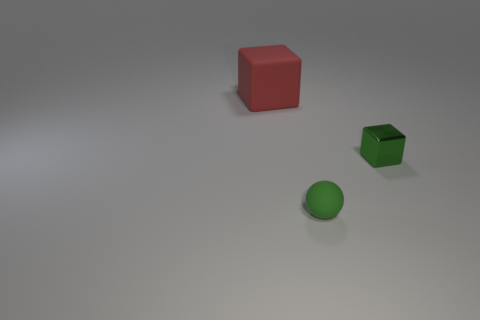Can you describe the positioning of the objects relative to each other? Certainly! In the image, we have three objects on a flat surface. On the left, there’s a red cube. To its right, and slightly towards the front, there's a green rubber sphere. Finally, in line with the sphere but further to the right, is a small green metal cube. 